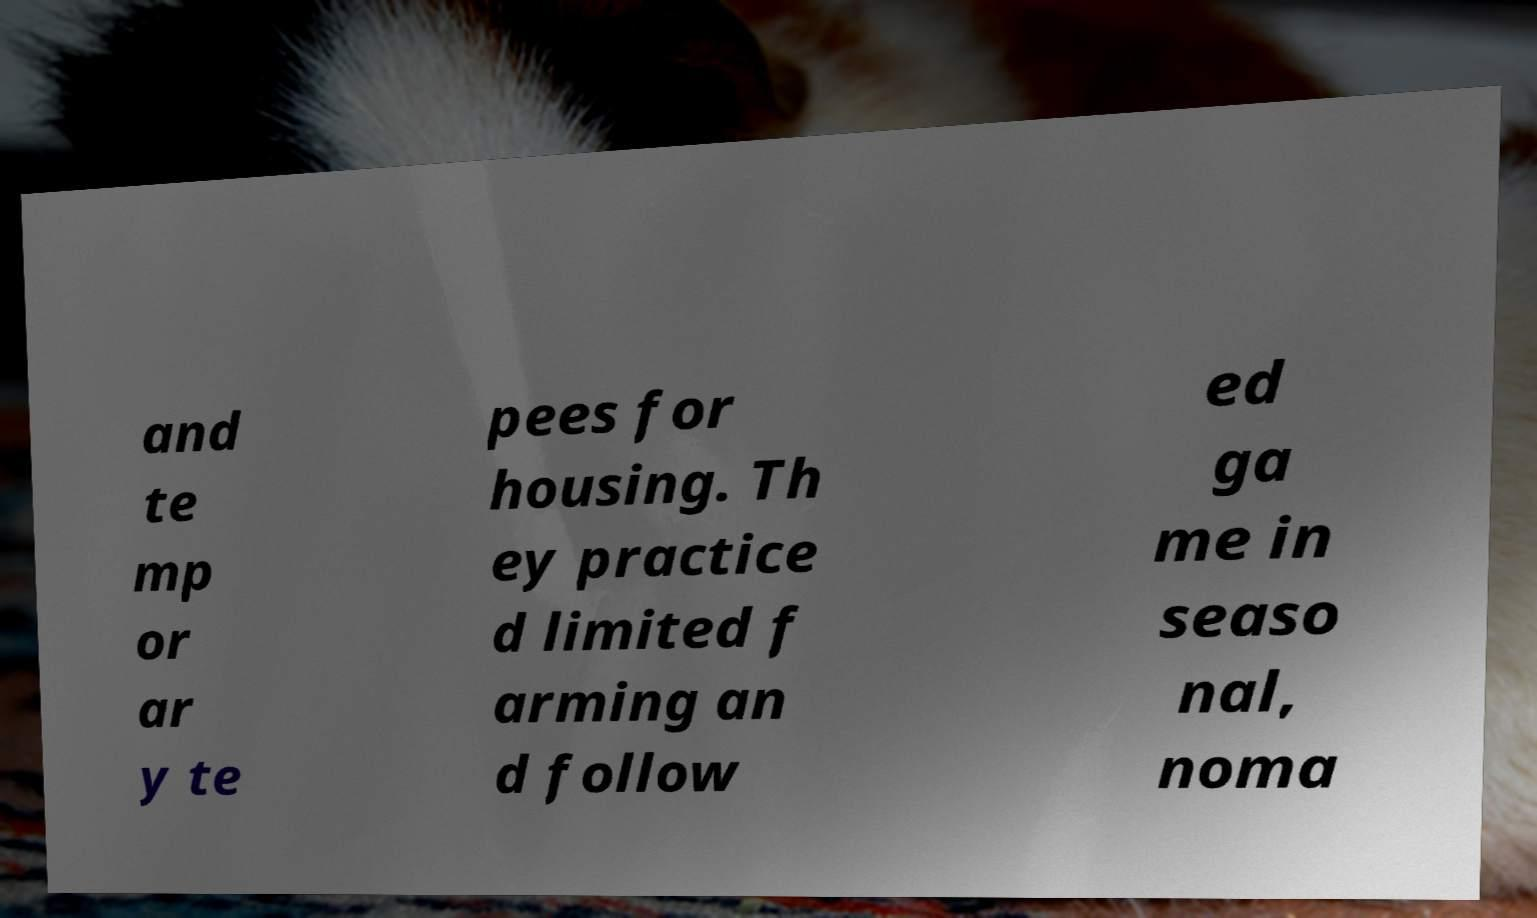Can you read and provide the text displayed in the image?This photo seems to have some interesting text. Can you extract and type it out for me? and te mp or ar y te pees for housing. Th ey practice d limited f arming an d follow ed ga me in seaso nal, noma 